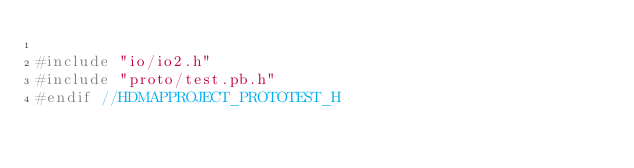<code> <loc_0><loc_0><loc_500><loc_500><_C_>
#include "io/io2.h"
#include "proto/test.pb.h"
#endif //HDMAPPROJECT_PROTOTEST_H
</code> 